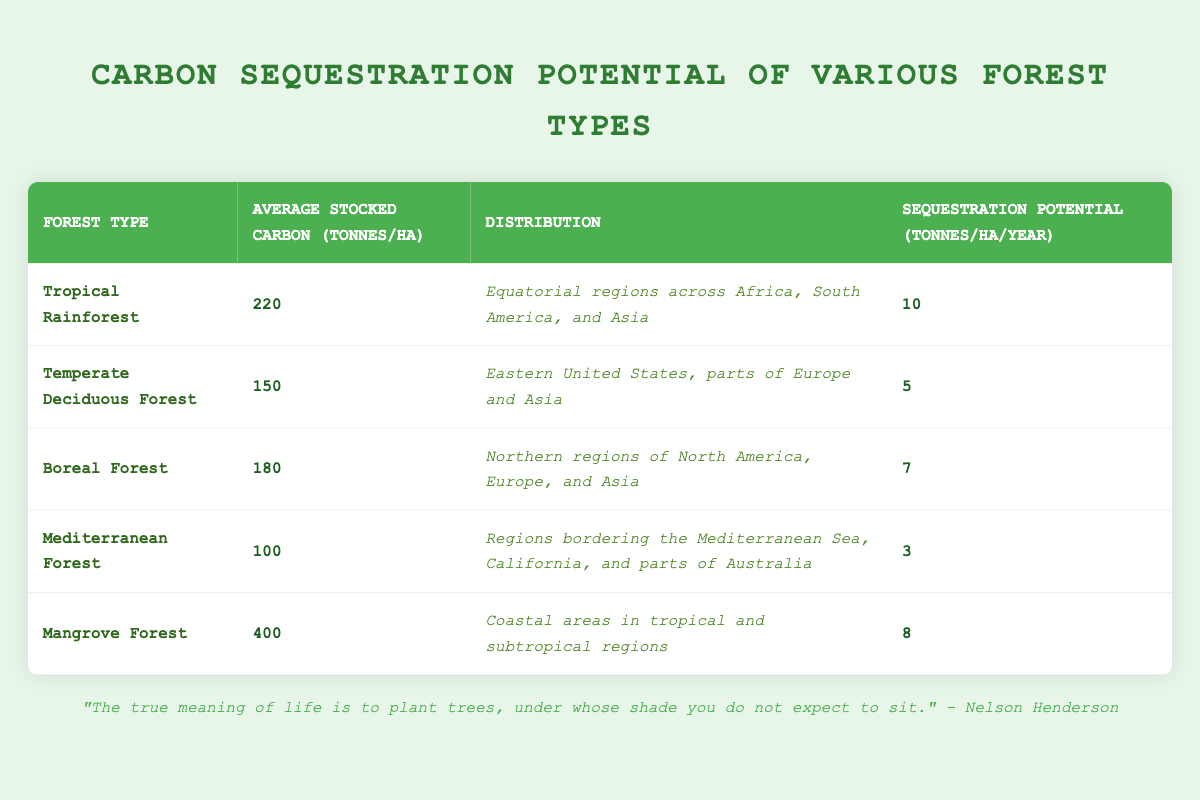What is the sequestration potential of Tropical Rainforest? The table shows that the sequestration potential per year for Tropical Rainforest is 10 tonnes per hectare.
Answer: 10 tonnes per hectare Which forest type has the highest average stocked carbon? By comparing the average stocked carbon values listed in the table, Mangrove Forest has the highest value at 400 tonnes per hectare.
Answer: 400 tonnes per hectare Is the average stocked carbon of Temperate Deciduous Forest greater than that of Boreal Forest? The average stocked carbon for Temperate Deciduous Forest is 150 tonnes per hectare, while for Boreal Forest it is 180 tonnes per hectare. Since 150 is less than 180, the statement is false.
Answer: No What is the average sequestration potential of all forest types listed in the table? First, identify the sequestration potentials: 10, 5, 7, 3, and 8. The sum is (10 + 5 + 7 + 3 + 8) = 33. There are 5 forest types, so the average is 33/5 = 6.6 tonnes per hectare per year.
Answer: 6.6 tonnes per hectare per year Which forest type has a distribution in coastal areas? The only forest type listed with a distribution in coastal areas is Mangrove Forest, as mentioned in the corresponding row of the table.
Answer: Mangrove Forest How many forest types have a sequestration potential of more than 6 tonnes per hectare per year? Review the sequestration potentials: Tropical Rainforest (10), Boreal Forest (7), and Mangrove Forest (8). Three forest types exceed 6 tonnes per hectare per year.
Answer: 3 What is the difference in average stocked carbon between Tropical Rainforest and Mediterranean Forest? The average stocked carbon for Tropical Rainforest is 220 tonnes per hectare, and for Mediterranean Forest, it is 100 tonnes per hectare. The difference is 220 - 100 = 120 tonnes per hectare.
Answer: 120 tonnes per hectare Is the distribution of Temperate Deciduous Forest limited to North America? The table describes the distribution of Temperate Deciduous Forest as being in the Eastern United States, parts of Europe and Asia. Therefore, it is not limited to North America, making the statement false.
Answer: No Which forest type has the lowest sequestration potential per year and what is that value? The table indicates that Mediterranean Forest has the lowest sequestration potential at 3 tonnes per hectare per year.
Answer: 3 tonnes per hectare per year 